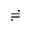<formula> <loc_0><loc_0><loc_500><loc_500>\risingdotseq</formula> 